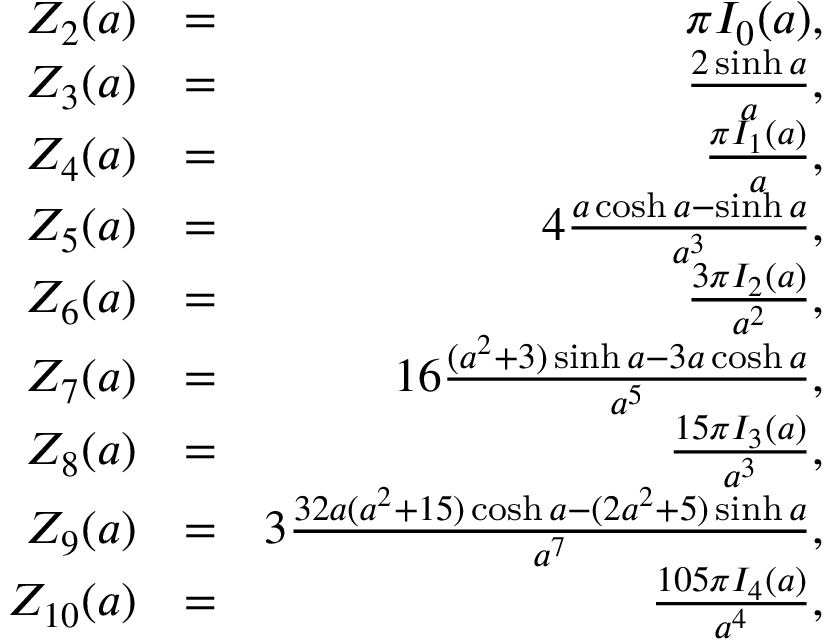Convert formula to latex. <formula><loc_0><loc_0><loc_500><loc_500>\begin{array} { r l r } { Z _ { 2 } ( a ) } & { = } & { \pi I _ { 0 } ( a ) , } \\ { Z _ { 3 } ( a ) } & { = } & { \frac { 2 \sinh a } { a } , } \\ { Z _ { 4 } ( a ) } & { = } & { \frac { \pi I _ { 1 } ( a ) } { a } , } \\ { Z _ { 5 } ( a ) } & { = } & { 4 \frac { a \cosh a - \sinh a } { a ^ { 3 } } , } \\ { Z _ { 6 } ( a ) } & { = } & { \frac { 3 \pi I _ { 2 } ( a ) } { a ^ { 2 } } , } \\ { Z _ { 7 } ( a ) } & { = } & { 1 6 \frac { ( a ^ { 2 } + 3 ) \sinh a - 3 a \cosh a } { a ^ { 5 } } , } \\ { Z _ { 8 } ( a ) } & { = } & { \frac { 1 5 \pi I _ { 3 } ( a ) } { a ^ { 3 } } , } \\ { Z _ { 9 } ( a ) } & { = } & { 3 \frac { 3 2 a ( a ^ { 2 } + 1 5 ) \cosh a - ( 2 a ^ { 2 } + 5 ) \sinh a } { a ^ { 7 } } , } \\ { Z _ { 1 0 } ( a ) } & { = } & { \frac { 1 0 5 \pi I _ { 4 } ( a ) } { a ^ { 4 } } , } \end{array}</formula> 